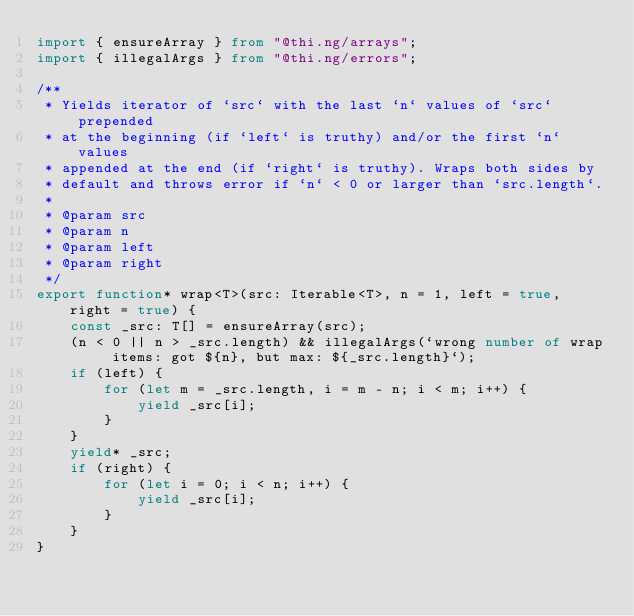<code> <loc_0><loc_0><loc_500><loc_500><_TypeScript_>import { ensureArray } from "@thi.ng/arrays";
import { illegalArgs } from "@thi.ng/errors";

/**
 * Yields iterator of `src` with the last `n` values of `src` prepended
 * at the beginning (if `left` is truthy) and/or the first `n` values
 * appended at the end (if `right` is truthy). Wraps both sides by
 * default and throws error if `n` < 0 or larger than `src.length`.
 *
 * @param src
 * @param n
 * @param left
 * @param right
 */
export function* wrap<T>(src: Iterable<T>, n = 1, left = true, right = true) {
    const _src: T[] = ensureArray(src);
    (n < 0 || n > _src.length) && illegalArgs(`wrong number of wrap items: got ${n}, but max: ${_src.length}`);
    if (left) {
        for (let m = _src.length, i = m - n; i < m; i++) {
            yield _src[i];
        }
    }
    yield* _src;
    if (right) {
        for (let i = 0; i < n; i++) {
            yield _src[i];
        }
    }
}
</code> 